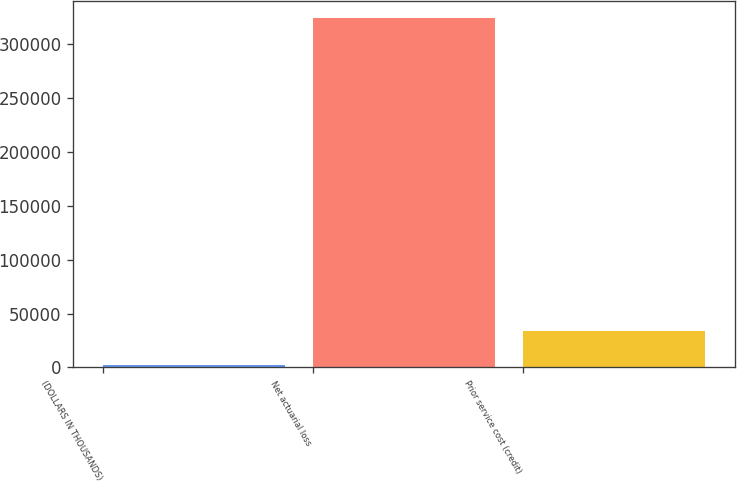Convert chart to OTSL. <chart><loc_0><loc_0><loc_500><loc_500><bar_chart><fcel>(DOLLARS IN THOUSANDS)<fcel>Net actuarial loss<fcel>Prior service cost (credit)<nl><fcel>2015<fcel>324068<fcel>34220.3<nl></chart> 